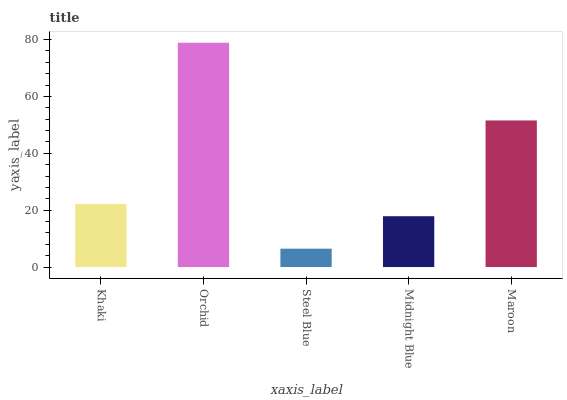Is Steel Blue the minimum?
Answer yes or no. Yes. Is Orchid the maximum?
Answer yes or no. Yes. Is Orchid the minimum?
Answer yes or no. No. Is Steel Blue the maximum?
Answer yes or no. No. Is Orchid greater than Steel Blue?
Answer yes or no. Yes. Is Steel Blue less than Orchid?
Answer yes or no. Yes. Is Steel Blue greater than Orchid?
Answer yes or no. No. Is Orchid less than Steel Blue?
Answer yes or no. No. Is Khaki the high median?
Answer yes or no. Yes. Is Khaki the low median?
Answer yes or no. Yes. Is Midnight Blue the high median?
Answer yes or no. No. Is Midnight Blue the low median?
Answer yes or no. No. 